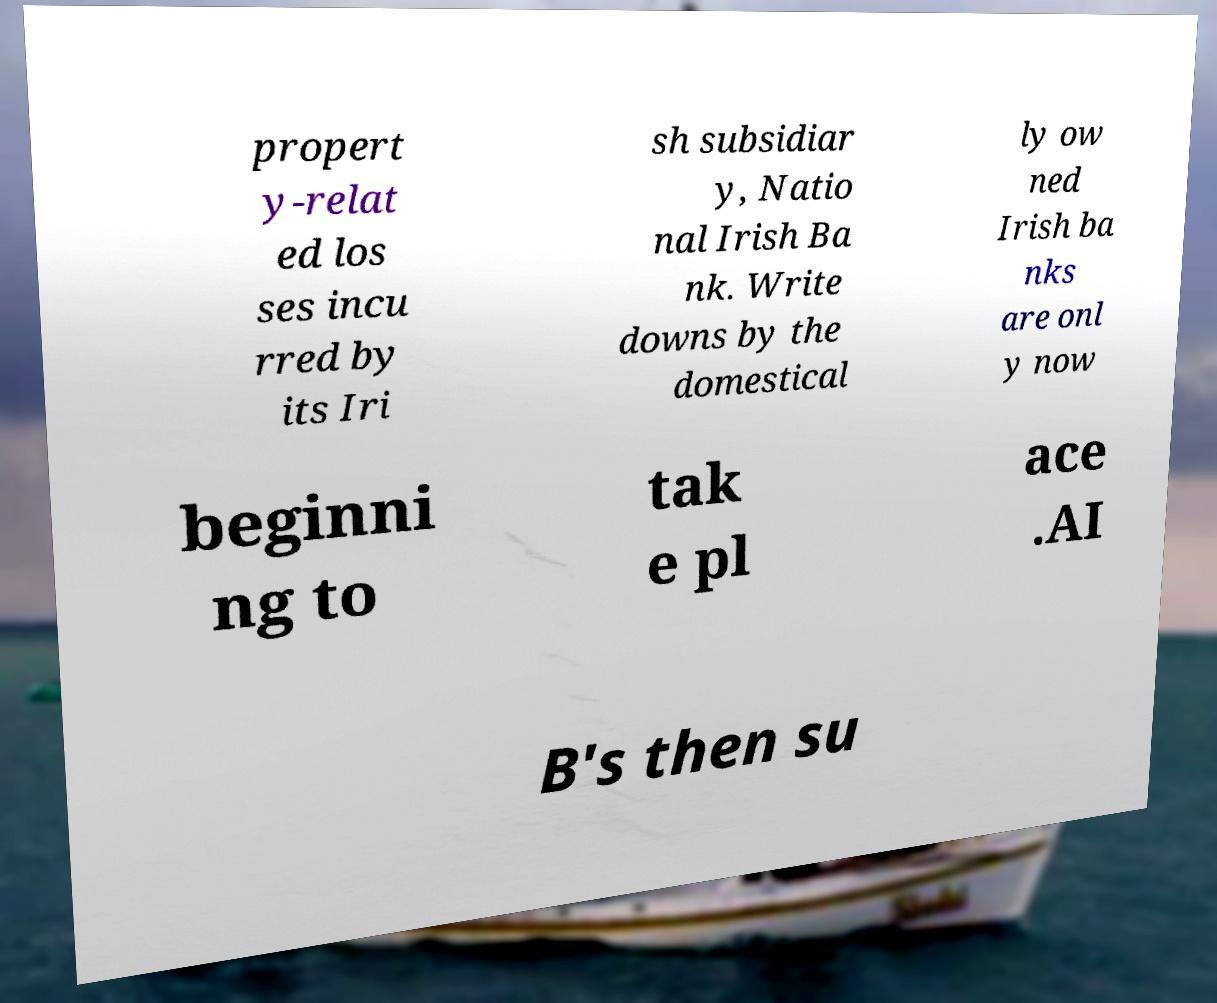Can you accurately transcribe the text from the provided image for me? propert y-relat ed los ses incu rred by its Iri sh subsidiar y, Natio nal Irish Ba nk. Write downs by the domestical ly ow ned Irish ba nks are onl y now beginni ng to tak e pl ace .AI B's then su 